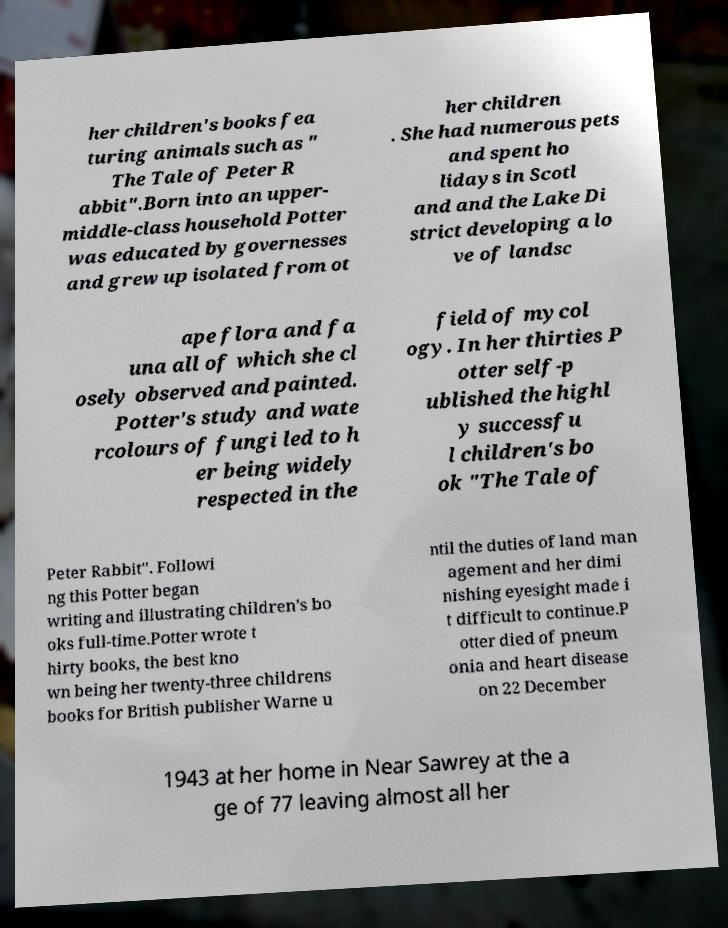Could you assist in decoding the text presented in this image and type it out clearly? her children's books fea turing animals such as " The Tale of Peter R abbit".Born into an upper- middle-class household Potter was educated by governesses and grew up isolated from ot her children . She had numerous pets and spent ho lidays in Scotl and and the Lake Di strict developing a lo ve of landsc ape flora and fa una all of which she cl osely observed and painted. Potter's study and wate rcolours of fungi led to h er being widely respected in the field of mycol ogy. In her thirties P otter self-p ublished the highl y successfu l children's bo ok "The Tale of Peter Rabbit". Followi ng this Potter began writing and illustrating children's bo oks full-time.Potter wrote t hirty books, the best kno wn being her twenty-three childrens books for British publisher Warne u ntil the duties of land man agement and her dimi nishing eyesight made i t difficult to continue.P otter died of pneum onia and heart disease on 22 December 1943 at her home in Near Sawrey at the a ge of 77 leaving almost all her 